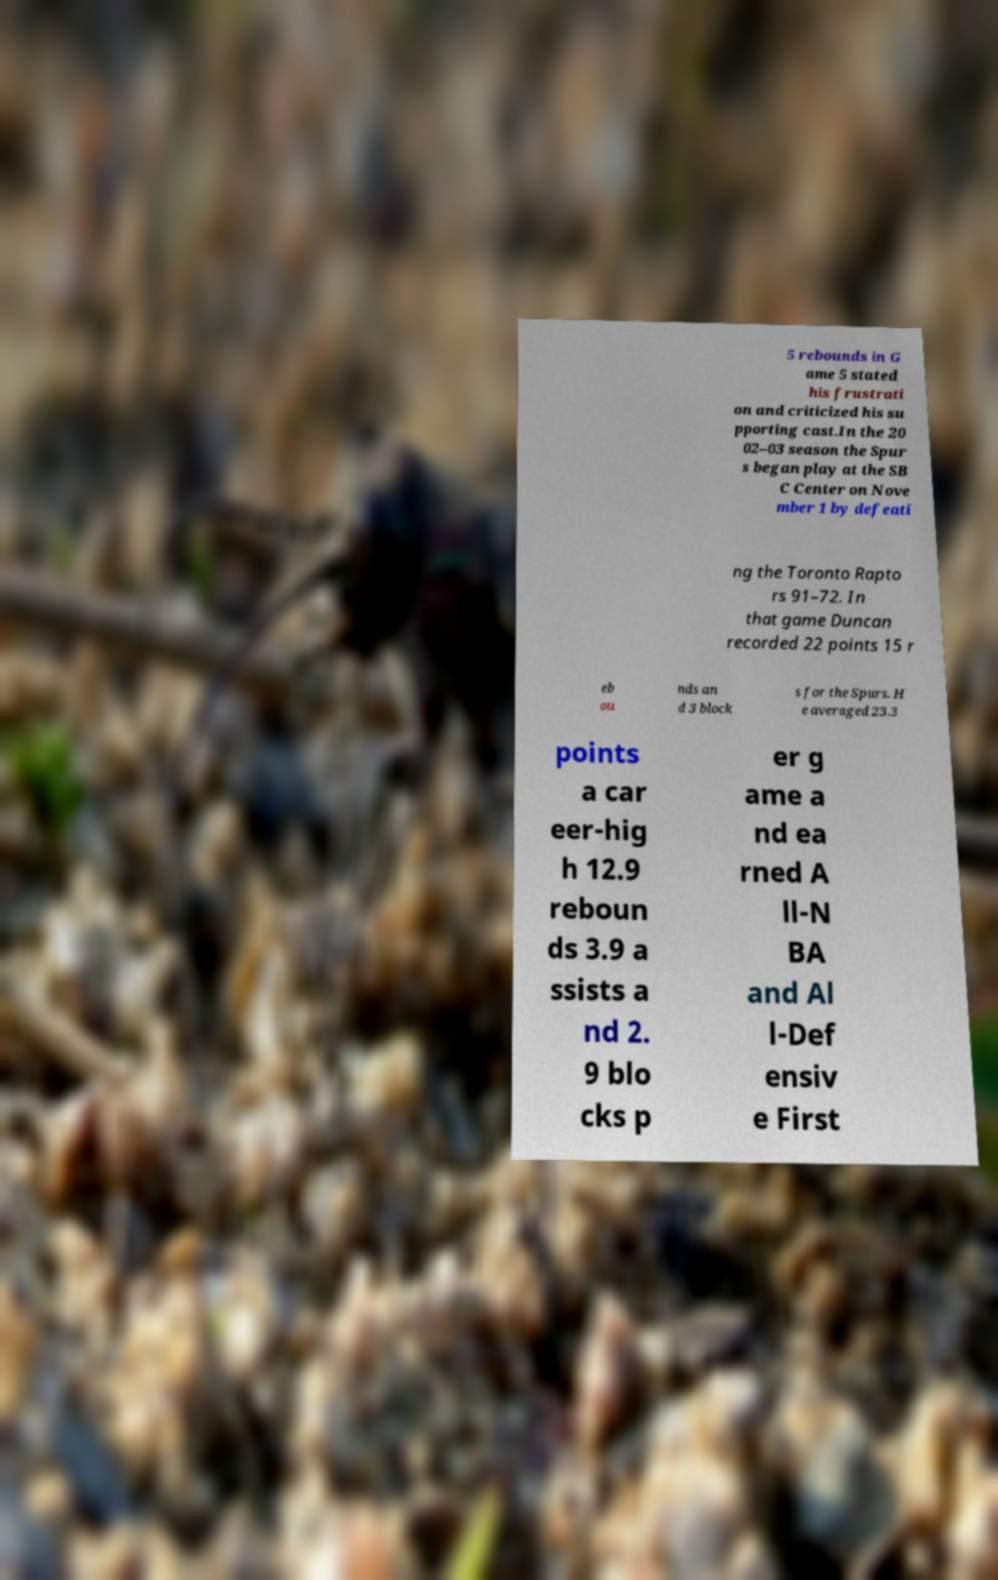There's text embedded in this image that I need extracted. Can you transcribe it verbatim? 5 rebounds in G ame 5 stated his frustrati on and criticized his su pporting cast.In the 20 02–03 season the Spur s began play at the SB C Center on Nove mber 1 by defeati ng the Toronto Rapto rs 91–72. In that game Duncan recorded 22 points 15 r eb ou nds an d 3 block s for the Spurs. H e averaged 23.3 points a car eer-hig h 12.9 reboun ds 3.9 a ssists a nd 2. 9 blo cks p er g ame a nd ea rned A ll-N BA and Al l-Def ensiv e First 